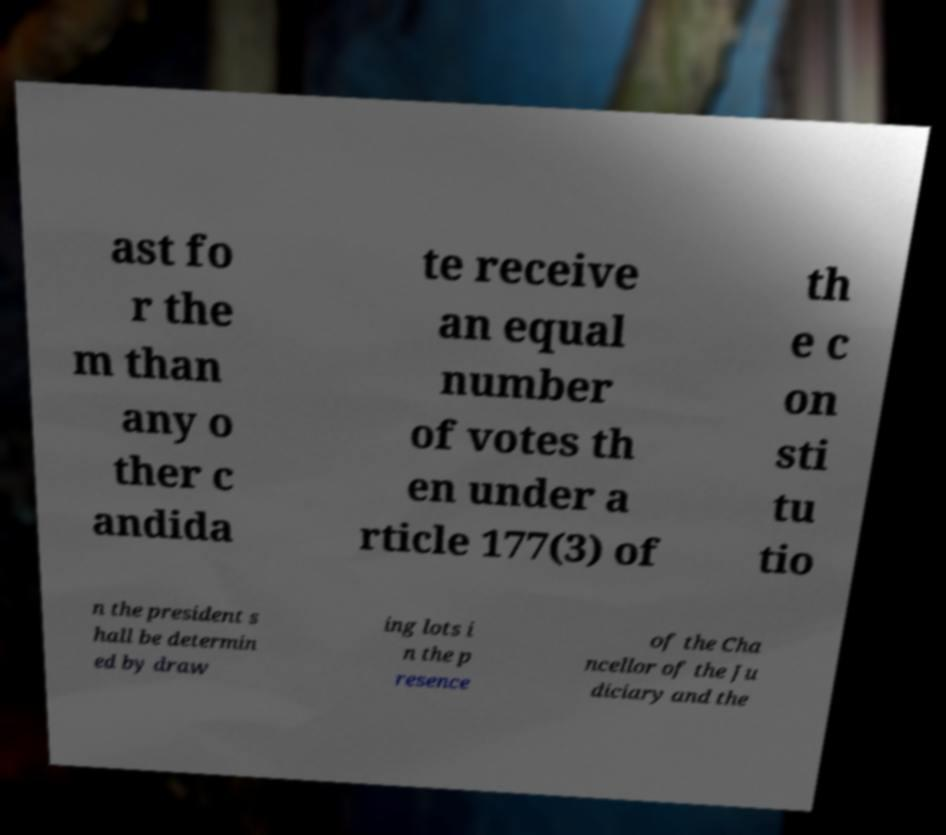Please read and relay the text visible in this image. What does it say? ast fo r the m than any o ther c andida te receive an equal number of votes th en under a rticle 177(3) of th e c on sti tu tio n the president s hall be determin ed by draw ing lots i n the p resence of the Cha ncellor of the Ju diciary and the 